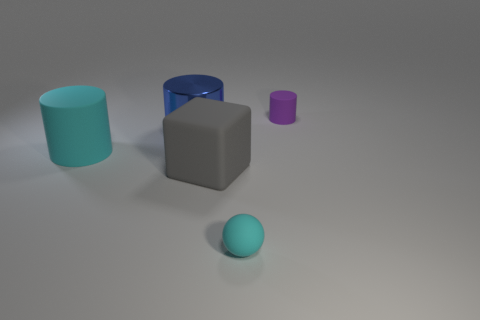Add 4 metallic blocks. How many objects exist? 9 Subtract all spheres. How many objects are left? 4 Add 5 big gray things. How many big gray things exist? 6 Subtract 0 green balls. How many objects are left? 5 Subtract all gray metal cylinders. Subtract all cubes. How many objects are left? 4 Add 4 cylinders. How many cylinders are left? 7 